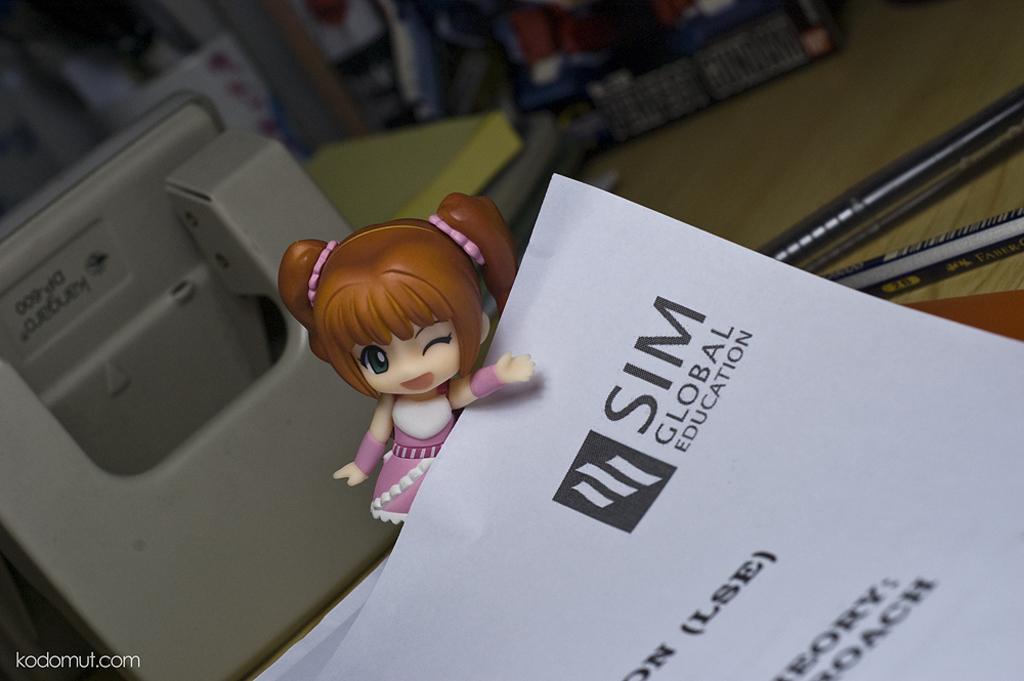How would you summarize this image in a sentence or two? We can see toy,papers,pens and some objects on wooden surface. Background it is blur. 